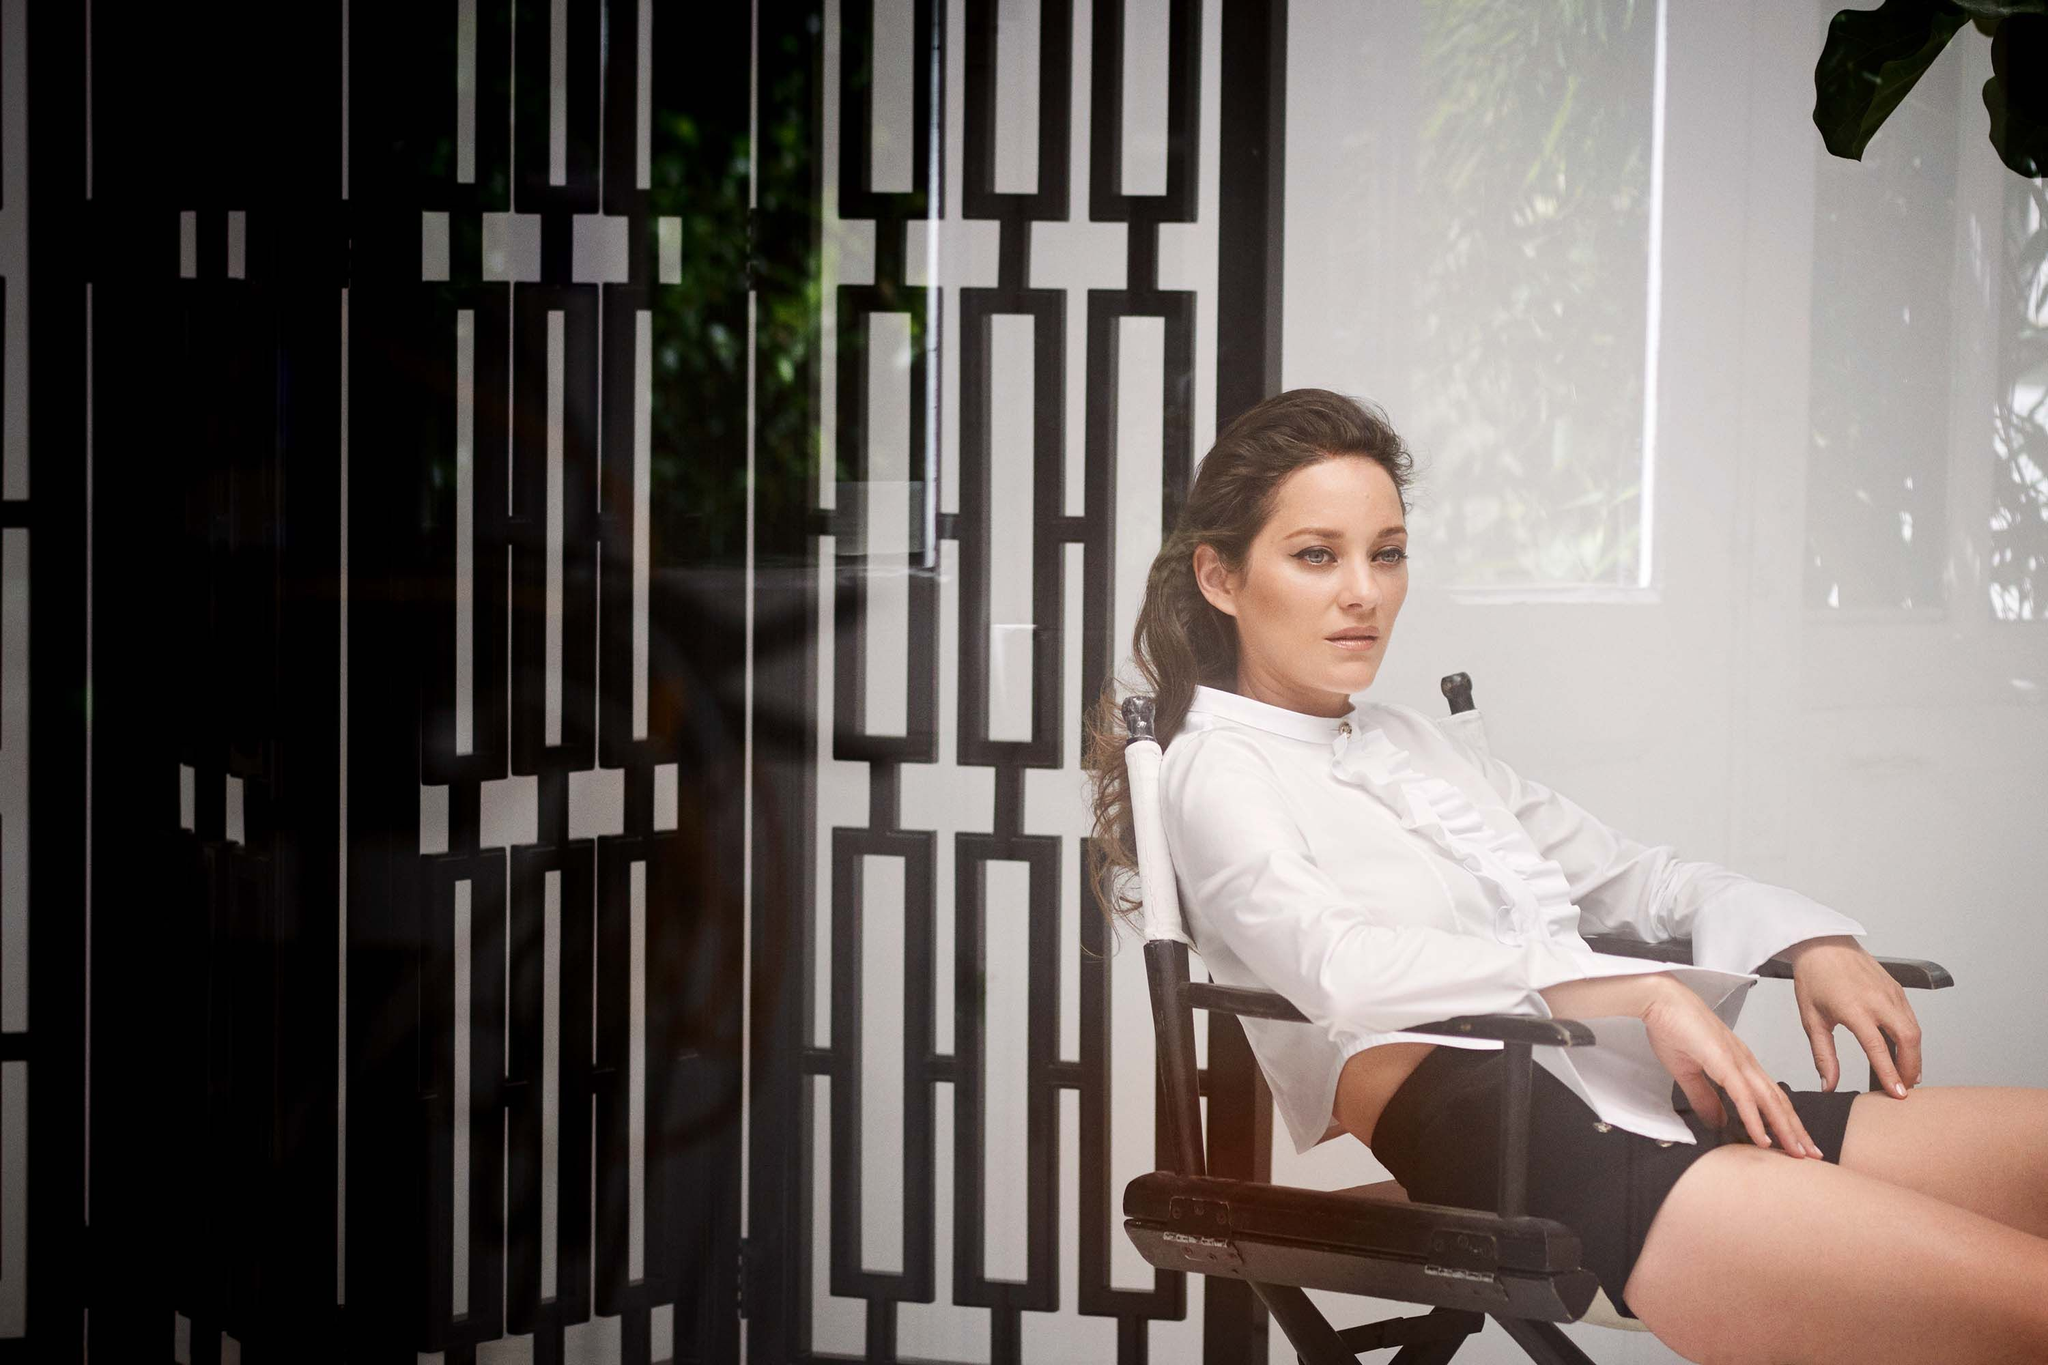What's the mood conveyed by this image? The mood conveyed by this image is one of quiet contemplation and introspection. The woman's thoughtful gaze and relaxed posture contribute to a serene and reflective atmosphere. The monochromatic color scheme of her clothing and the geometric pattern on the wall add a sense of elegance and sophistication. Why do you think the geometric pattern on the wall is significant? The geometric pattern on the wall adds a visually interesting and sophisticated backdrop to the image. It contrasts with the relaxed composure of the woman, creating a balance between complexity and calm. This pattern might symbolize structure and order, perhaps reflecting the organized and creative environment of a film set or studio where the photo might have been taken. Imagine the story behind this photo. What might it be? In a quiet corner of a bustling film set, the woman has just finished an intense scene. She takes a moment to sit back and reflect on her performance. The director's chair and the backdrop of geometric patterns provide a sharp contrast to her thoughts swirling with the emotions of her character. This could be a brief pause before the next scene, capturing a candid and deeply human moment in the life of an actress. Can you describe the setting in more detail as if you were there? The setting appears to be a well-appointed interior, likely part of a studio or a creatively designed space on a film set. The wall's black and white geometric pattern catches the eye, creating a sense of depth and modern artistry. The woman, seated on a sturdy wooden director's chair, seems to be positioned near tall windows, suggested by the soft natural light illuminating her face and creating subtle reflections. The ambience is calm, almost reverent, allowing for introspective moments amidst what might otherwise be an environment bustling with creative activity. 